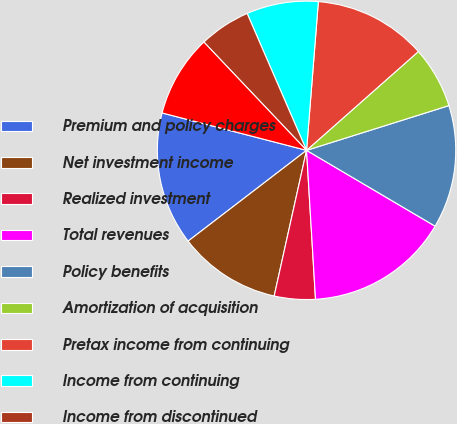Convert chart to OTSL. <chart><loc_0><loc_0><loc_500><loc_500><pie_chart><fcel>Premium and policy charges<fcel>Net investment income<fcel>Realized investment<fcel>Total revenues<fcel>Policy benefits<fcel>Amortization of acquisition<fcel>Pretax income from continuing<fcel>Income from continuing<fcel>Income from discontinued<fcel>Net income<nl><fcel>14.44%<fcel>11.11%<fcel>4.44%<fcel>15.56%<fcel>13.33%<fcel>6.67%<fcel>12.22%<fcel>7.78%<fcel>5.56%<fcel>8.89%<nl></chart> 